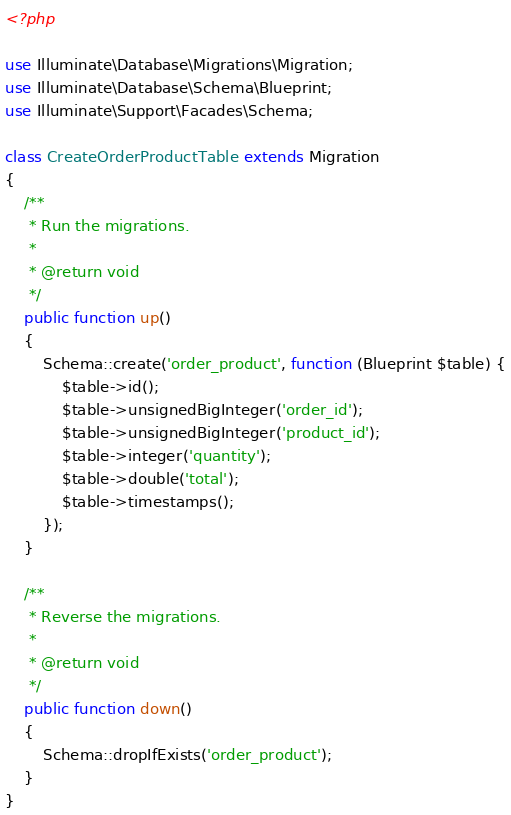Convert code to text. <code><loc_0><loc_0><loc_500><loc_500><_PHP_><?php

use Illuminate\Database\Migrations\Migration;
use Illuminate\Database\Schema\Blueprint;
use Illuminate\Support\Facades\Schema;

class CreateOrderProductTable extends Migration
{
    /**
     * Run the migrations.
     *
     * @return void
     */
    public function up()
    {
        Schema::create('order_product', function (Blueprint $table) {
            $table->id();
            $table->unsignedBigInteger('order_id');
            $table->unsignedBigInteger('product_id');
            $table->integer('quantity');
            $table->double('total');
            $table->timestamps();
        });
    }

    /**
     * Reverse the migrations.
     *
     * @return void
     */
    public function down()
    {
        Schema::dropIfExists('order_product');
    }
}
</code> 